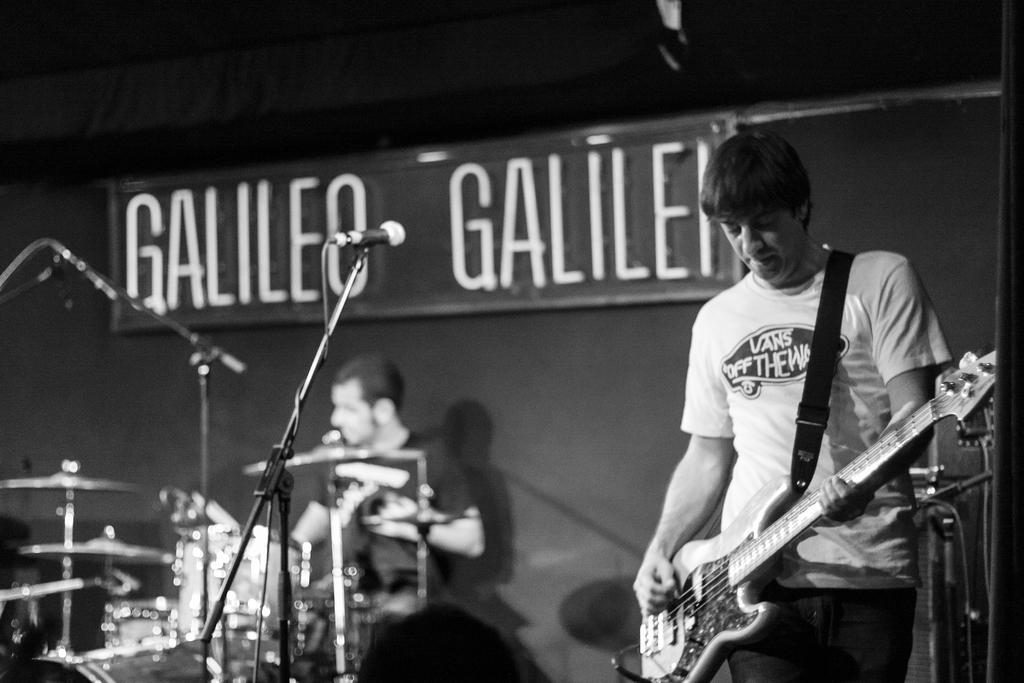What is the man on the right side of the image doing? The man is standing on the right side of the image and holding a guitar. What object is in front of the man? There is a microphone in front of the man. What can be seen in the background of the image? There is a wall in the background of the image, as well as a person sitting and musical instruments. What time is the owner of the key arriving in the image? There is no mention of a key or an owner in the image, so it is not possible to answer this question. 